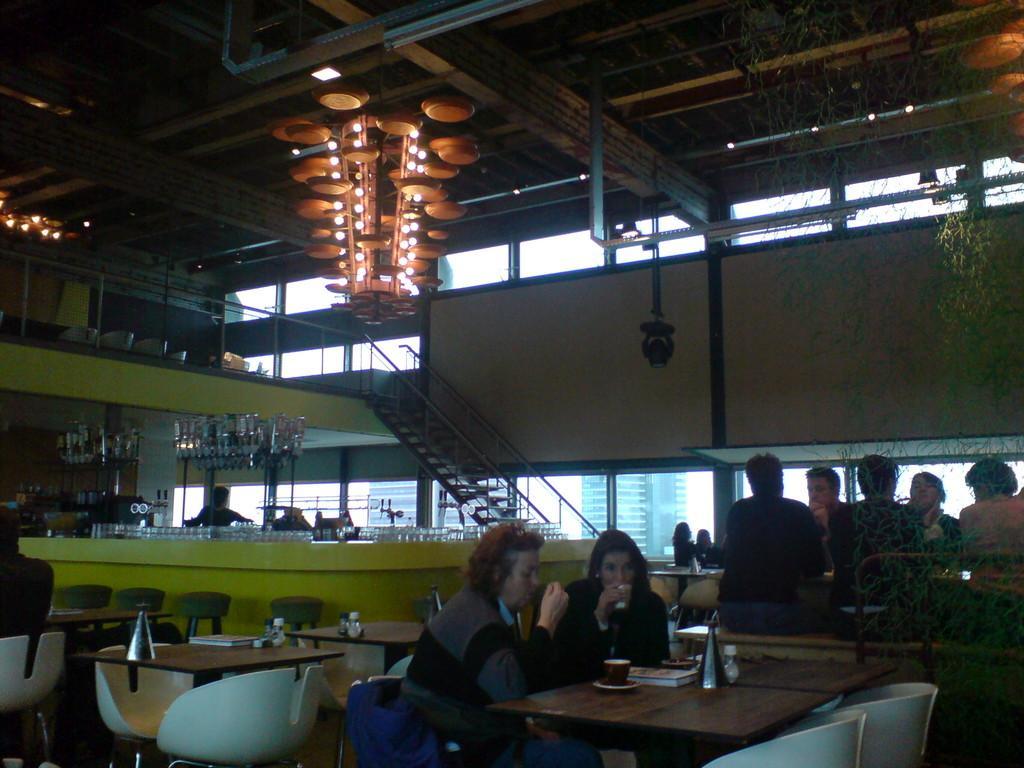Can you describe this image briefly? On top there are lights. Few persons are sitting on chairs. Far this person is standing. On this table there are glasses. We can able to see chairs and tables. These are steps. 